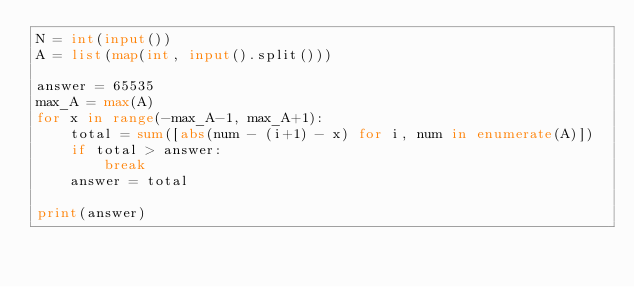Convert code to text. <code><loc_0><loc_0><loc_500><loc_500><_Python_>N = int(input())
A = list(map(int, input().split()))

answer = 65535
max_A = max(A)
for x in range(-max_A-1, max_A+1):
    total = sum([abs(num - (i+1) - x) for i, num in enumerate(A)])
    if total > answer:
        break
    answer = total

print(answer)</code> 